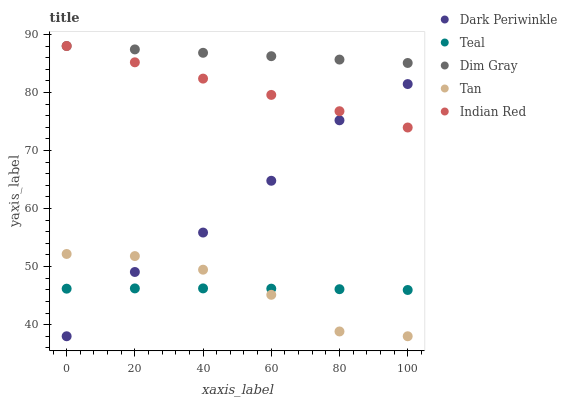Does Tan have the minimum area under the curve?
Answer yes or no. Yes. Does Dim Gray have the maximum area under the curve?
Answer yes or no. Yes. Does Dim Gray have the minimum area under the curve?
Answer yes or no. No. Does Tan have the maximum area under the curve?
Answer yes or no. No. Is Dim Gray the smoothest?
Answer yes or no. Yes. Is Dark Periwinkle the roughest?
Answer yes or no. Yes. Is Tan the smoothest?
Answer yes or no. No. Is Tan the roughest?
Answer yes or no. No. Does Tan have the lowest value?
Answer yes or no. Yes. Does Dim Gray have the lowest value?
Answer yes or no. No. Does Dim Gray have the highest value?
Answer yes or no. Yes. Does Tan have the highest value?
Answer yes or no. No. Is Tan less than Dim Gray?
Answer yes or no. Yes. Is Indian Red greater than Teal?
Answer yes or no. Yes. Does Dim Gray intersect Indian Red?
Answer yes or no. Yes. Is Dim Gray less than Indian Red?
Answer yes or no. No. Is Dim Gray greater than Indian Red?
Answer yes or no. No. Does Tan intersect Dim Gray?
Answer yes or no. No. 